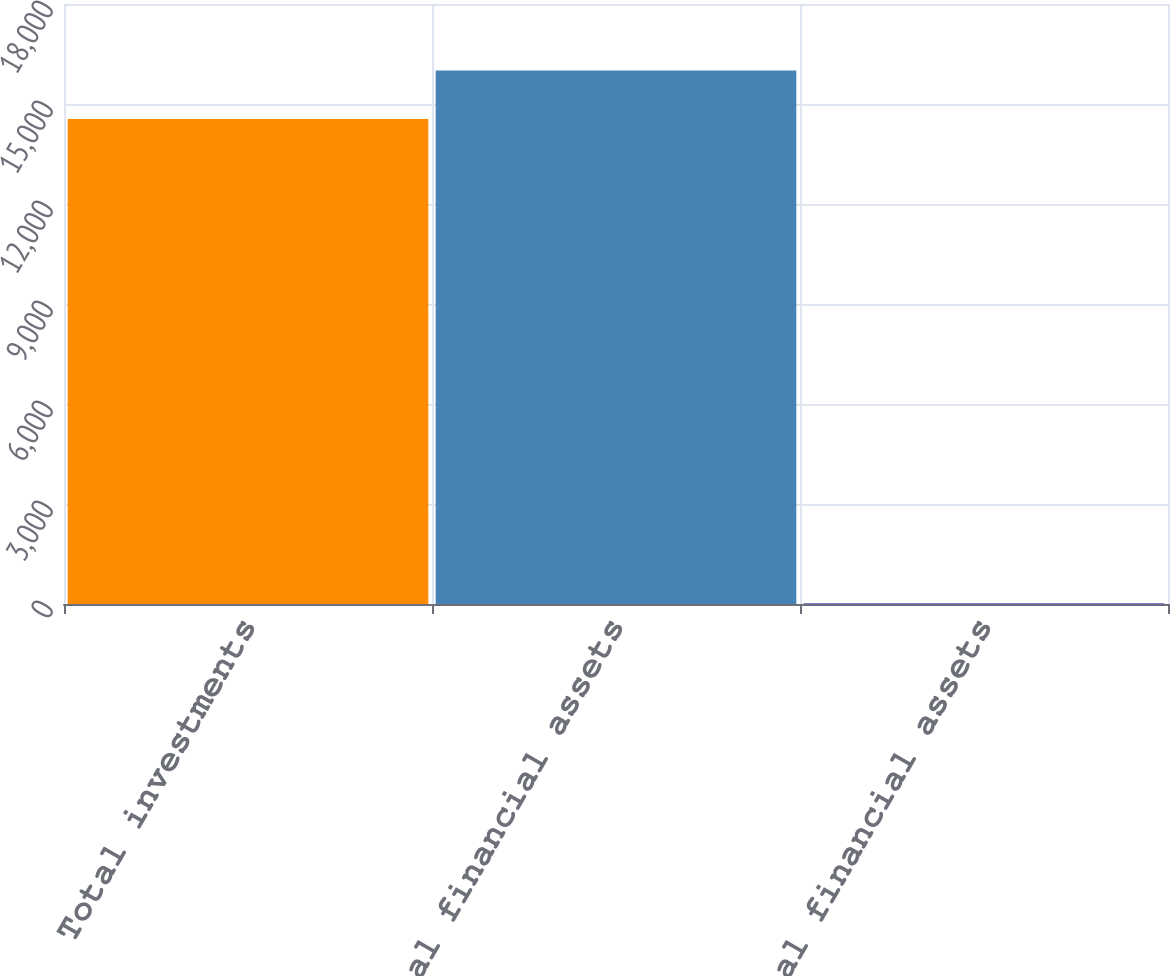<chart> <loc_0><loc_0><loc_500><loc_500><bar_chart><fcel>Total investments<fcel>Total financial assets<fcel>of total financial assets<nl><fcel>14553<fcel>16006.9<fcel>14<nl></chart> 